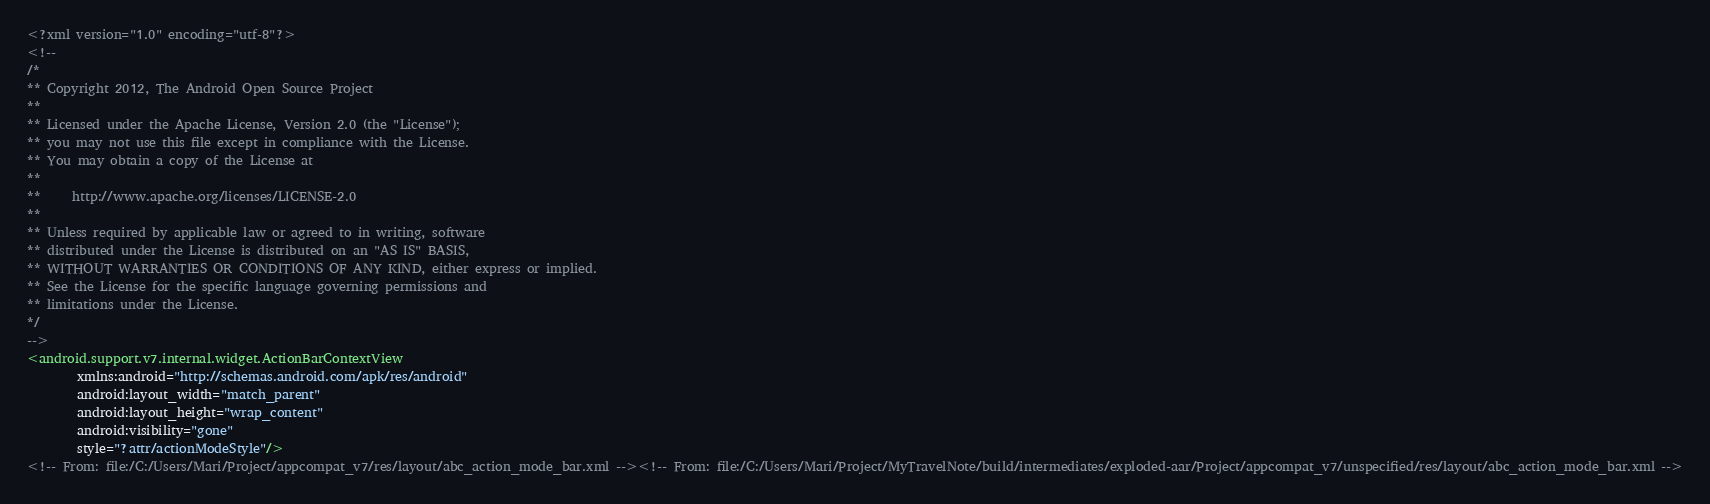<code> <loc_0><loc_0><loc_500><loc_500><_XML_><?xml version="1.0" encoding="utf-8"?>
<!--
/*
** Copyright 2012, The Android Open Source Project
**
** Licensed under the Apache License, Version 2.0 (the "License");
** you may not use this file except in compliance with the License.
** You may obtain a copy of the License at
**
**     http://www.apache.org/licenses/LICENSE-2.0
**
** Unless required by applicable law or agreed to in writing, software
** distributed under the License is distributed on an "AS IS" BASIS,
** WITHOUT WARRANTIES OR CONDITIONS OF ANY KIND, either express or implied.
** See the License for the specific language governing permissions and
** limitations under the License.
*/
-->
<android.support.v7.internal.widget.ActionBarContextView
        xmlns:android="http://schemas.android.com/apk/res/android"
        android:layout_width="match_parent"
        android:layout_height="wrap_content"
        android:visibility="gone"
        style="?attr/actionModeStyle"/>
<!-- From: file:/C:/Users/Mari/Project/appcompat_v7/res/layout/abc_action_mode_bar.xml --><!-- From: file:/C:/Users/Mari/Project/MyTravelNote/build/intermediates/exploded-aar/Project/appcompat_v7/unspecified/res/layout/abc_action_mode_bar.xml --></code> 